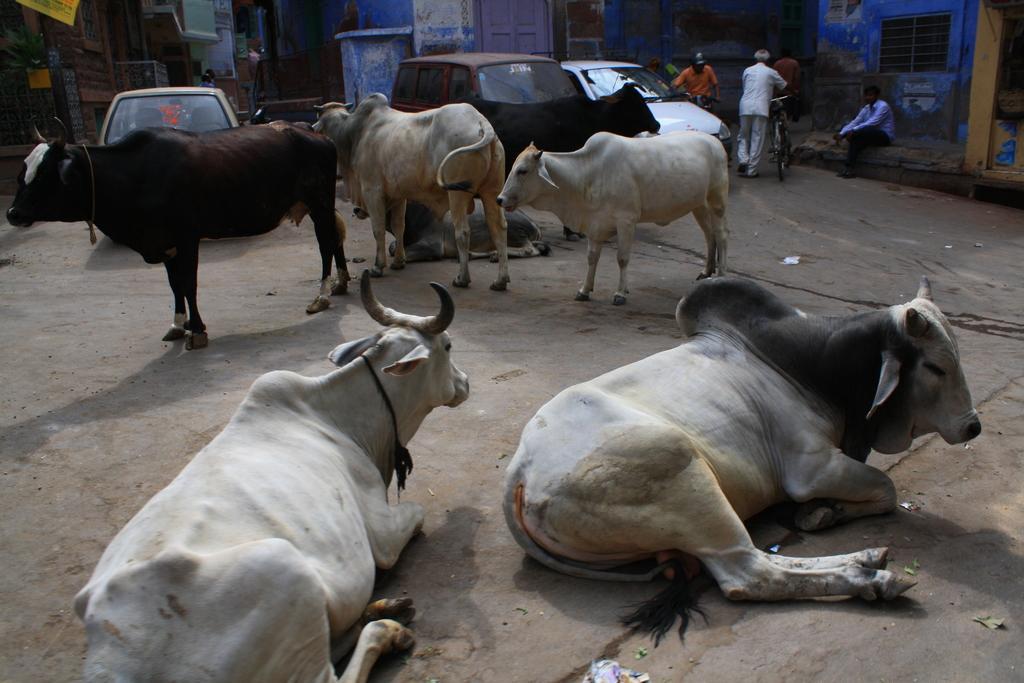Please provide a concise description of this image. In this image, we can see animals and vehicles. There are some persons in the top right of the image wearing clothes. There are buildings at the top of the image. 